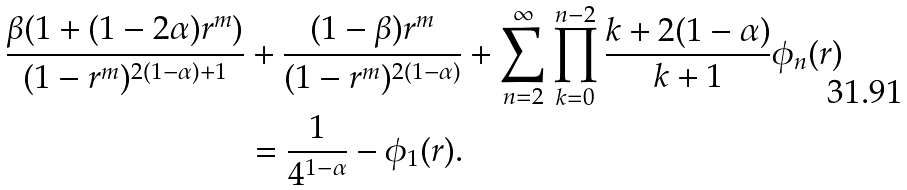Convert formula to latex. <formula><loc_0><loc_0><loc_500><loc_500>\frac { \beta ( 1 + ( 1 - 2 \alpha ) r ^ { m } ) } { ( 1 - r ^ { m } ) ^ { 2 ( 1 - \alpha ) + 1 } } & + \frac { ( 1 - \beta ) r ^ { m } } { ( 1 - r ^ { m } ) ^ { 2 ( 1 - \alpha ) } } + \sum _ { n = 2 } ^ { \infty } \prod _ { k = 0 } ^ { n - 2 } \frac { k + 2 ( 1 - \alpha ) } { k + 1 } \phi _ { n } ( r ) \\ & = \frac { 1 } { 4 ^ { 1 - \alpha } } - \phi _ { 1 } ( r ) .</formula> 